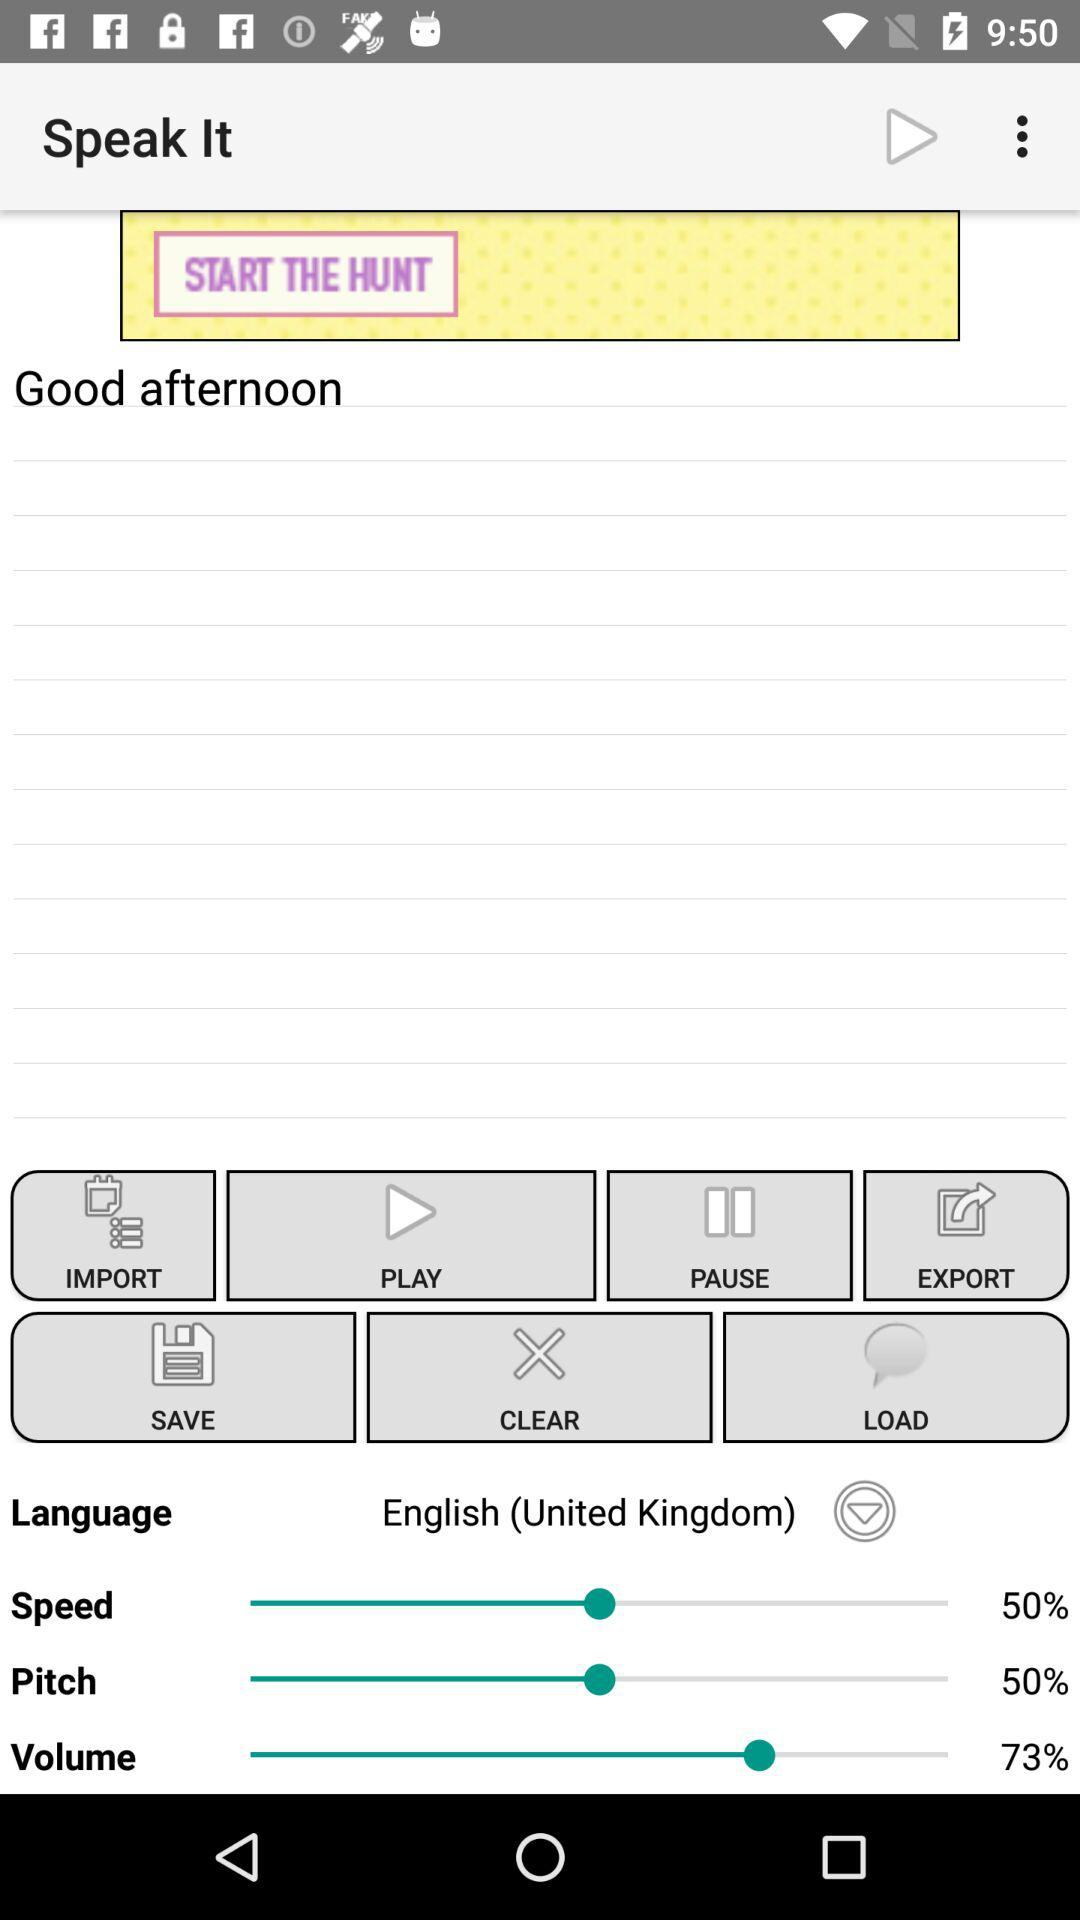What is the entered text? The entered text is "Good afternoon". 